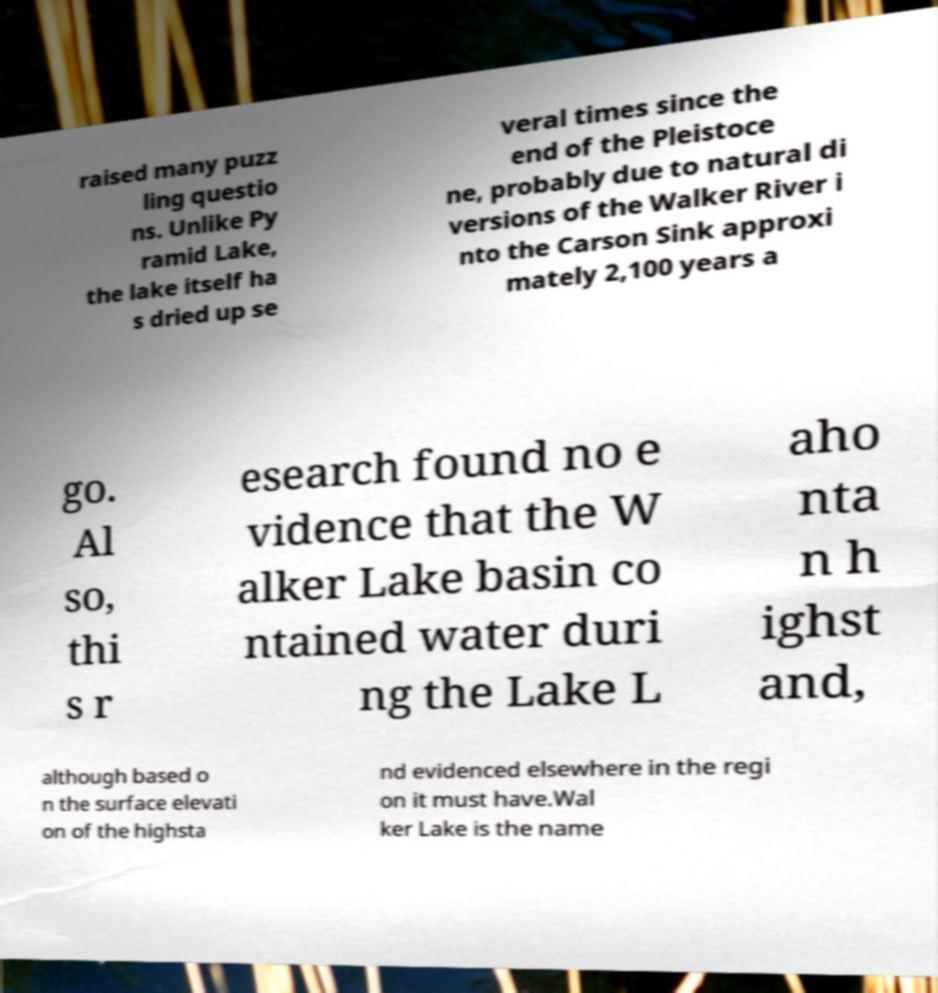Please identify and transcribe the text found in this image. raised many puzz ling questio ns. Unlike Py ramid Lake, the lake itself ha s dried up se veral times since the end of the Pleistoce ne, probably due to natural di versions of the Walker River i nto the Carson Sink approxi mately 2,100 years a go. Al so, thi s r esearch found no e vidence that the W alker Lake basin co ntained water duri ng the Lake L aho nta n h ighst and, although based o n the surface elevati on of the highsta nd evidenced elsewhere in the regi on it must have.Wal ker Lake is the name 